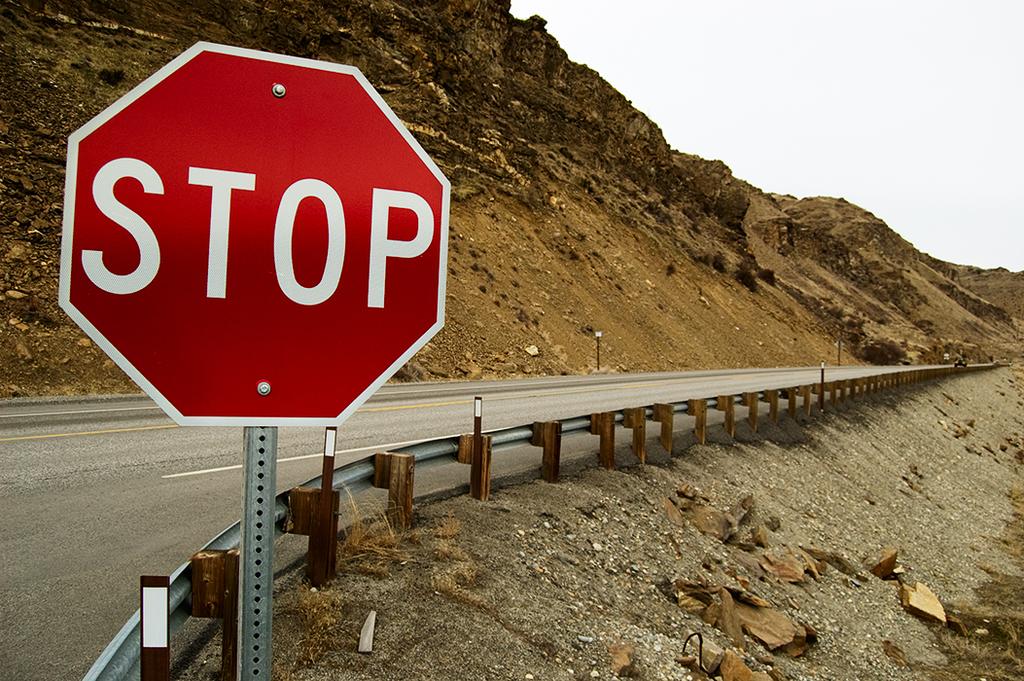What does the sign signify?
Keep it short and to the point. Stop. What does this sign say you should do?
Your response must be concise. Stop. 